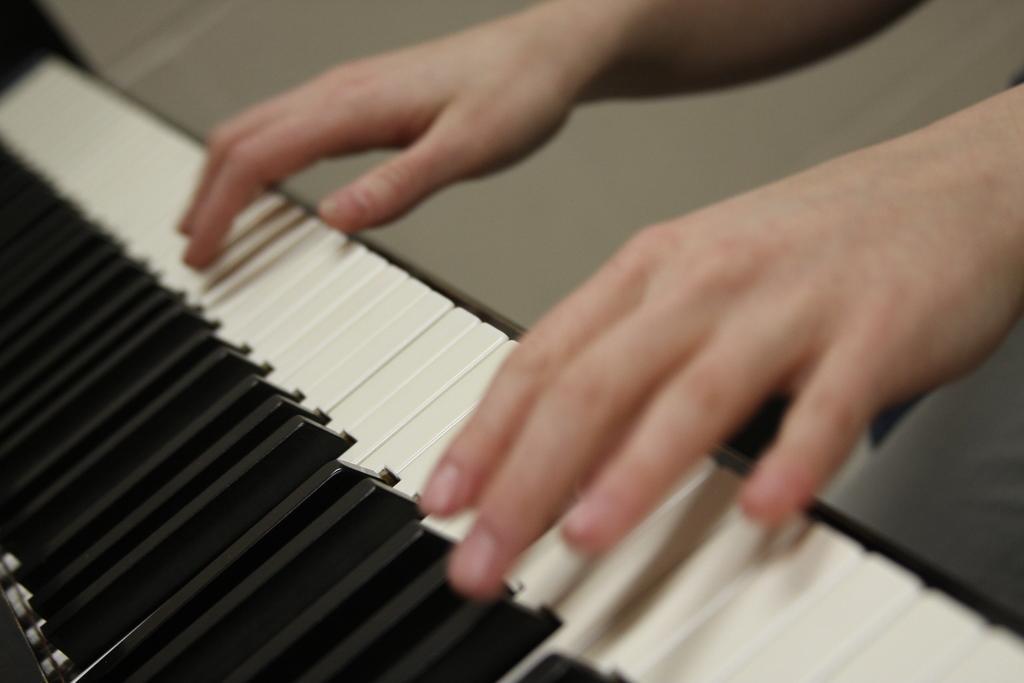Please provide a concise description of this image. In the image there is a person playing piano. 